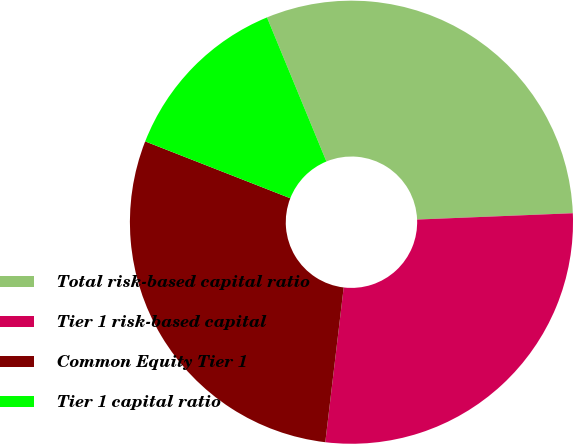Convert chart. <chart><loc_0><loc_0><loc_500><loc_500><pie_chart><fcel>Total risk-based capital ratio<fcel>Tier 1 risk-based capital<fcel>Common Equity Tier 1<fcel>Tier 1 capital ratio<nl><fcel>30.58%<fcel>27.53%<fcel>29.06%<fcel>12.83%<nl></chart> 